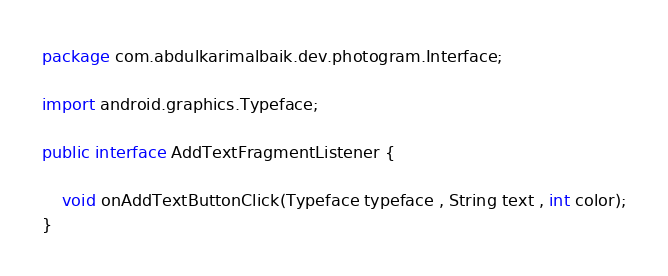Convert code to text. <code><loc_0><loc_0><loc_500><loc_500><_Java_>package com.abdulkarimalbaik.dev.photogram.Interface;

import android.graphics.Typeface;

public interface AddTextFragmentListener {

    void onAddTextButtonClick(Typeface typeface , String text , int color);
}
</code> 